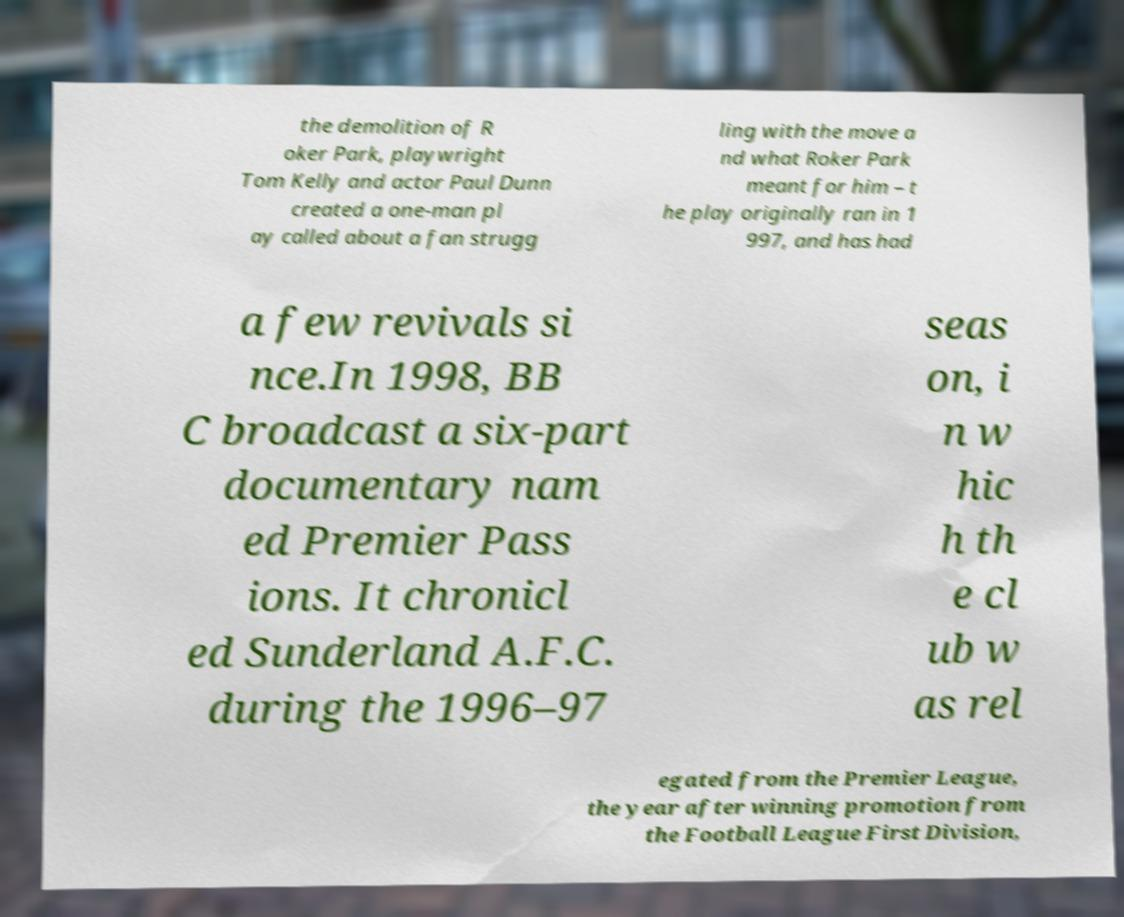Please read and relay the text visible in this image. What does it say? the demolition of R oker Park, playwright Tom Kelly and actor Paul Dunn created a one-man pl ay called about a fan strugg ling with the move a nd what Roker Park meant for him – t he play originally ran in 1 997, and has had a few revivals si nce.In 1998, BB C broadcast a six-part documentary nam ed Premier Pass ions. It chronicl ed Sunderland A.F.C. during the 1996–97 seas on, i n w hic h th e cl ub w as rel egated from the Premier League, the year after winning promotion from the Football League First Division, 